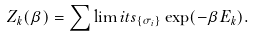<formula> <loc_0><loc_0><loc_500><loc_500>Z _ { k } ( \beta ) = \sum \lim i t s _ { \{ \sigma _ { i } \} } \exp ( - \beta E _ { k } ) .</formula> 